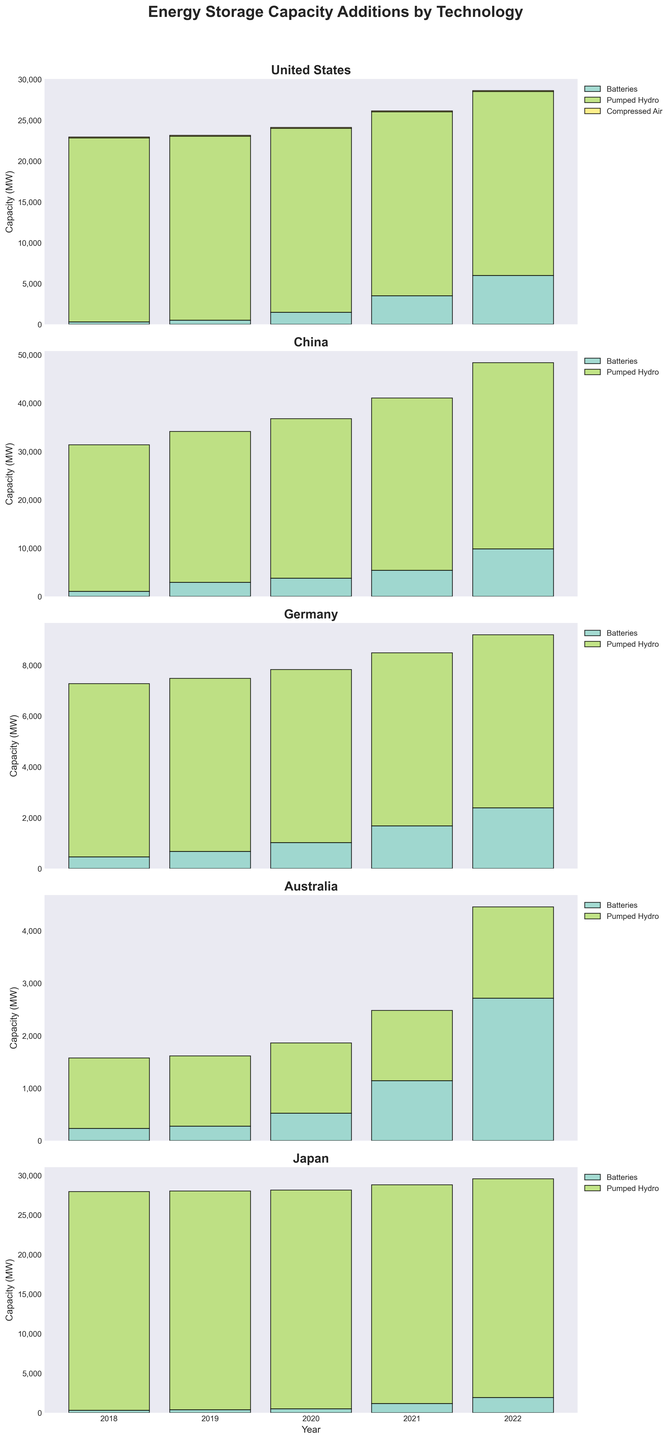What technology saw the largest capacity addition in the US in 2021? In 2021, the bar for Batteries in the US is significantly taller compared to other technologies, indicating it had the largest capacity addition.
Answer: Batteries How has the pumped hydro capacity in Germany changed from 2018 to 2022? Comparing the heights of the pumped hydro bars for Germany from 2018 to 2022, the bars remain constant, indicating no change in capacity.
Answer: No change Which country had the highest total energy storage capacity addition in 2022? By looking at the stacked bars for each country in 2022, China has the tallest bar, indicating the highest total energy storage capacity addition.
Answer: China What is the trend in battery storage capacity additions in Australia from 2018 to 2022? Observing the battery bars in Australia, there is a clear upward trend in the heights, showing increasing capacity additions each year.
Answer: Increasing Which country had the smallest capacity addition for compressed air technology across all years? The bars for compressed air in the US and only the US are depicted and remain constant and short, indicating the smallest capacity addition.
Answer: United States Compare the trend of battery storage capacity additions in the US and China from 2018 to 2022. Both countries show increasing trends in battery storage capacity additions from 2018 to 2022. However, the increase is steeper in China.
Answer: Both increasing, China steeper How did Japan's battery storage addition in 2020 compare to Australia's in the same year? The bar for batteries in Japan is slightly taller than the bar for batteries in Australia in 2020, indicating Japan had a higher capacity addition.
Answer: Japan higher What was the total energy storage capacity addition for Germany in 2019? Sum the heights of the battery and pumped hydro bars for Germany in 2019. Germany's capacity addition: 675 (batteries) + 6806 (pumped hydro).
Answer: 7481 MW Which technology contributed most to China's total energy storage capacity in 2022? In 2022, the majority of the height of the stacked bar for China is composed of pumped hydro, indicating it had the largest contribution.
Answer: Pumped Hydro What is the difference in pumped hydro capacity additions between Japan and the US in 2022? Check the heights of the pumped hydro bars in 2022 for both countries. Japan: 27637, US: 22509. The difference is 27637 - 22509.
Answer: 5128 MW 